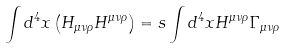Convert formula to latex. <formula><loc_0><loc_0><loc_500><loc_500>\int d ^ { 4 } x \left ( H _ { \mu \nu \rho } H ^ { \mu \nu \rho } \right ) = s \int d ^ { 4 } x H ^ { \mu \nu \rho } \Gamma _ { \mu \nu \rho }</formula> 